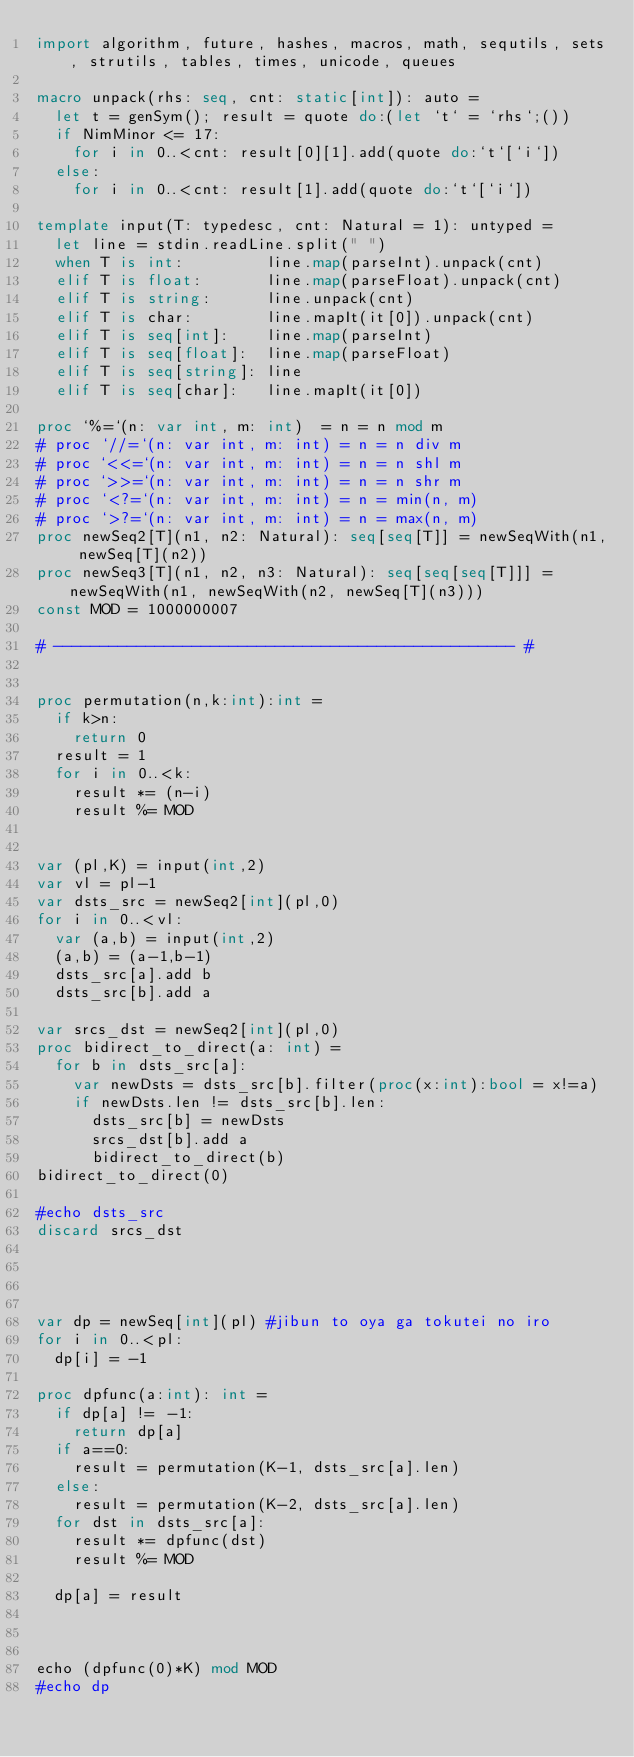Convert code to text. <code><loc_0><loc_0><loc_500><loc_500><_Nim_>import algorithm, future, hashes, macros, math, sequtils, sets, strutils, tables, times, unicode, queues
 
macro unpack(rhs: seq, cnt: static[int]): auto =
  let t = genSym(); result = quote do:(let `t` = `rhs`;())
  if NimMinor <= 17:
    for i in 0..<cnt: result[0][1].add(quote do:`t`[`i`])
  else:
    for i in 0..<cnt: result[1].add(quote do:`t`[`i`])
 
template input(T: typedesc, cnt: Natural = 1): untyped =
  let line = stdin.readLine.split(" ")
  when T is int:         line.map(parseInt).unpack(cnt)
  elif T is float:       line.map(parseFloat).unpack(cnt)
  elif T is string:      line.unpack(cnt)
  elif T is char:        line.mapIt(it[0]).unpack(cnt)
  elif T is seq[int]:    line.map(parseInt)
  elif T is seq[float]:  line.map(parseFloat)
  elif T is seq[string]: line
  elif T is seq[char]:   line.mapIt(it[0])
 
proc `%=`(n: var int, m: int)  = n = n mod m
# proc `//=`(n: var int, m: int) = n = n div m
# proc `<<=`(n: var int, m: int) = n = n shl m
# proc `>>=`(n: var int, m: int) = n = n shr m
# proc `<?=`(n: var int, m: int) = n = min(n, m)
# proc `>?=`(n: var int, m: int) = n = max(n, m)
proc newSeq2[T](n1, n2: Natural): seq[seq[T]] = newSeqWith(n1, newSeq[T](n2))
proc newSeq3[T](n1, n2, n3: Natural): seq[seq[seq[T]]] = newSeqWith(n1, newSeqWith(n2, newSeq[T](n3)))
const MOD = 1000000007

# -------------------------------------------------- #


proc permutation(n,k:int):int =
  if k>n:
    return 0
  result = 1
  for i in 0..<k:
    result *= (n-i)
    result %= MOD


var (pl,K) = input(int,2)
var vl = pl-1
var dsts_src = newSeq2[int](pl,0)
for i in 0..<vl:
  var (a,b) = input(int,2)
  (a,b) = (a-1,b-1)
  dsts_src[a].add b
  dsts_src[b].add a

var srcs_dst = newSeq2[int](pl,0)
proc bidirect_to_direct(a: int) =
  for b in dsts_src[a]:
    var newDsts = dsts_src[b].filter(proc(x:int):bool = x!=a)
    if newDsts.len != dsts_src[b].len:
      dsts_src[b] = newDsts
      srcs_dst[b].add a
      bidirect_to_direct(b)
bidirect_to_direct(0)

#echo dsts_src
discard srcs_dst




var dp = newSeq[int](pl) #jibun to oya ga tokutei no iro
for i in 0..<pl:
  dp[i] = -1

proc dpfunc(a:int): int =
  if dp[a] != -1:
    return dp[a]
  if a==0:
    result = permutation(K-1, dsts_src[a].len)
  else:
    result = permutation(K-2, dsts_src[a].len)
  for dst in dsts_src[a]:
    result *= dpfunc(dst)
    result %= MOD

  dp[a] = result



echo (dpfunc(0)*K) mod MOD
#echo dp



</code> 